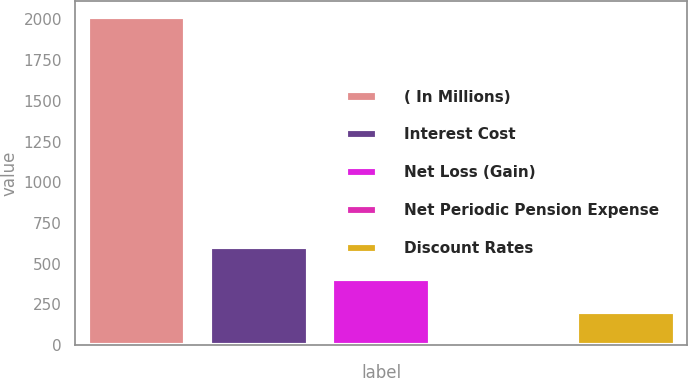Convert chart to OTSL. <chart><loc_0><loc_0><loc_500><loc_500><bar_chart><fcel>( In Millions)<fcel>Interest Cost<fcel>Net Loss (Gain)<fcel>Net Periodic Pension Expense<fcel>Discount Rates<nl><fcel>2014<fcel>604.55<fcel>403.2<fcel>0.5<fcel>201.85<nl></chart> 